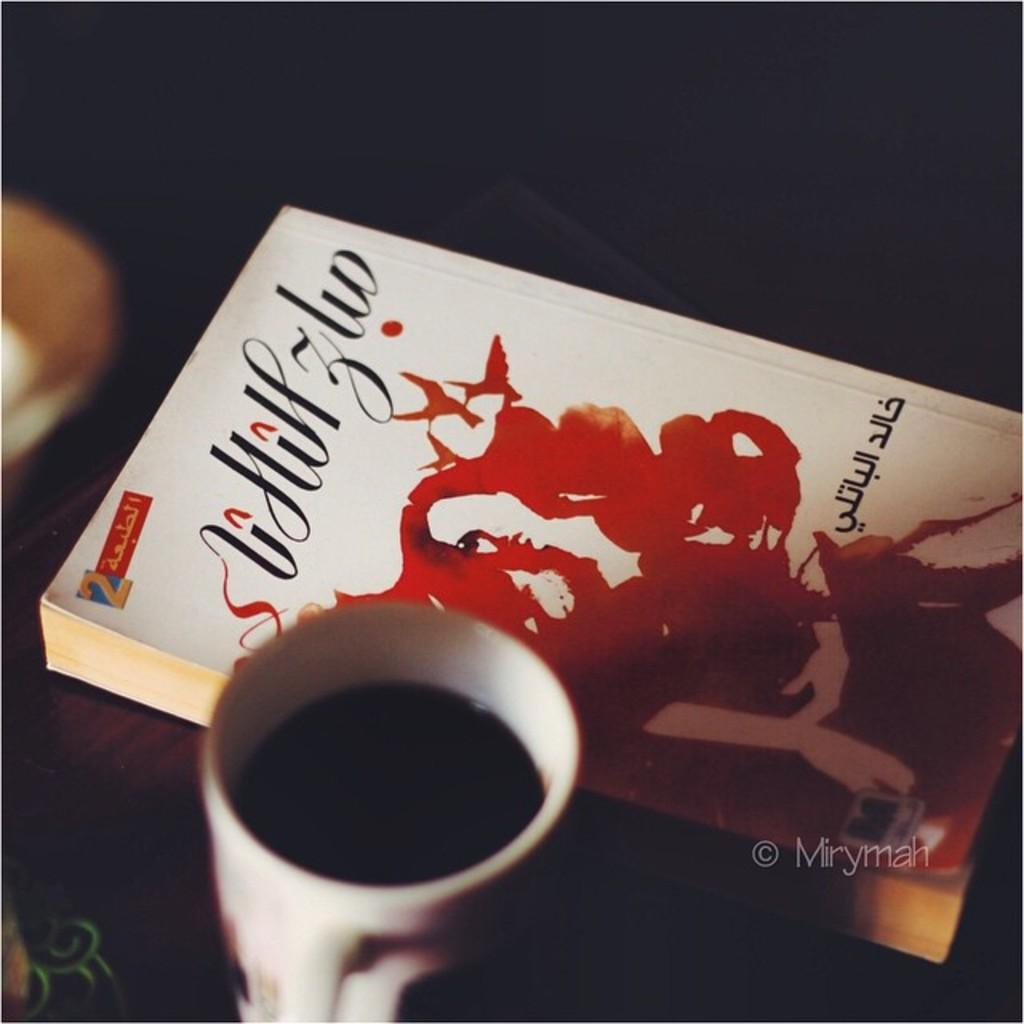What is located in the foreground of the image? There is a book and a coffee cup in the foreground of the image. What type of surface is visible in the foreground of the image? The wooden surface is in the foreground of the image. What can be seen on the left side of the image? There is an object on the left side of the image. How would you describe the lighting at the top of the image? The top of the image is dark. How does the bear interact with the dust in the image? There is no bear or dust present in the image. 